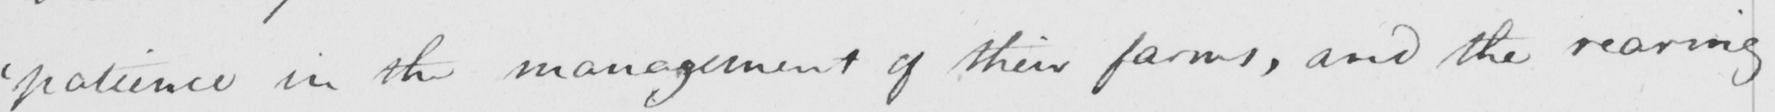Can you tell me what this handwritten text says? ' patience in the management of their farms , and the rearing 